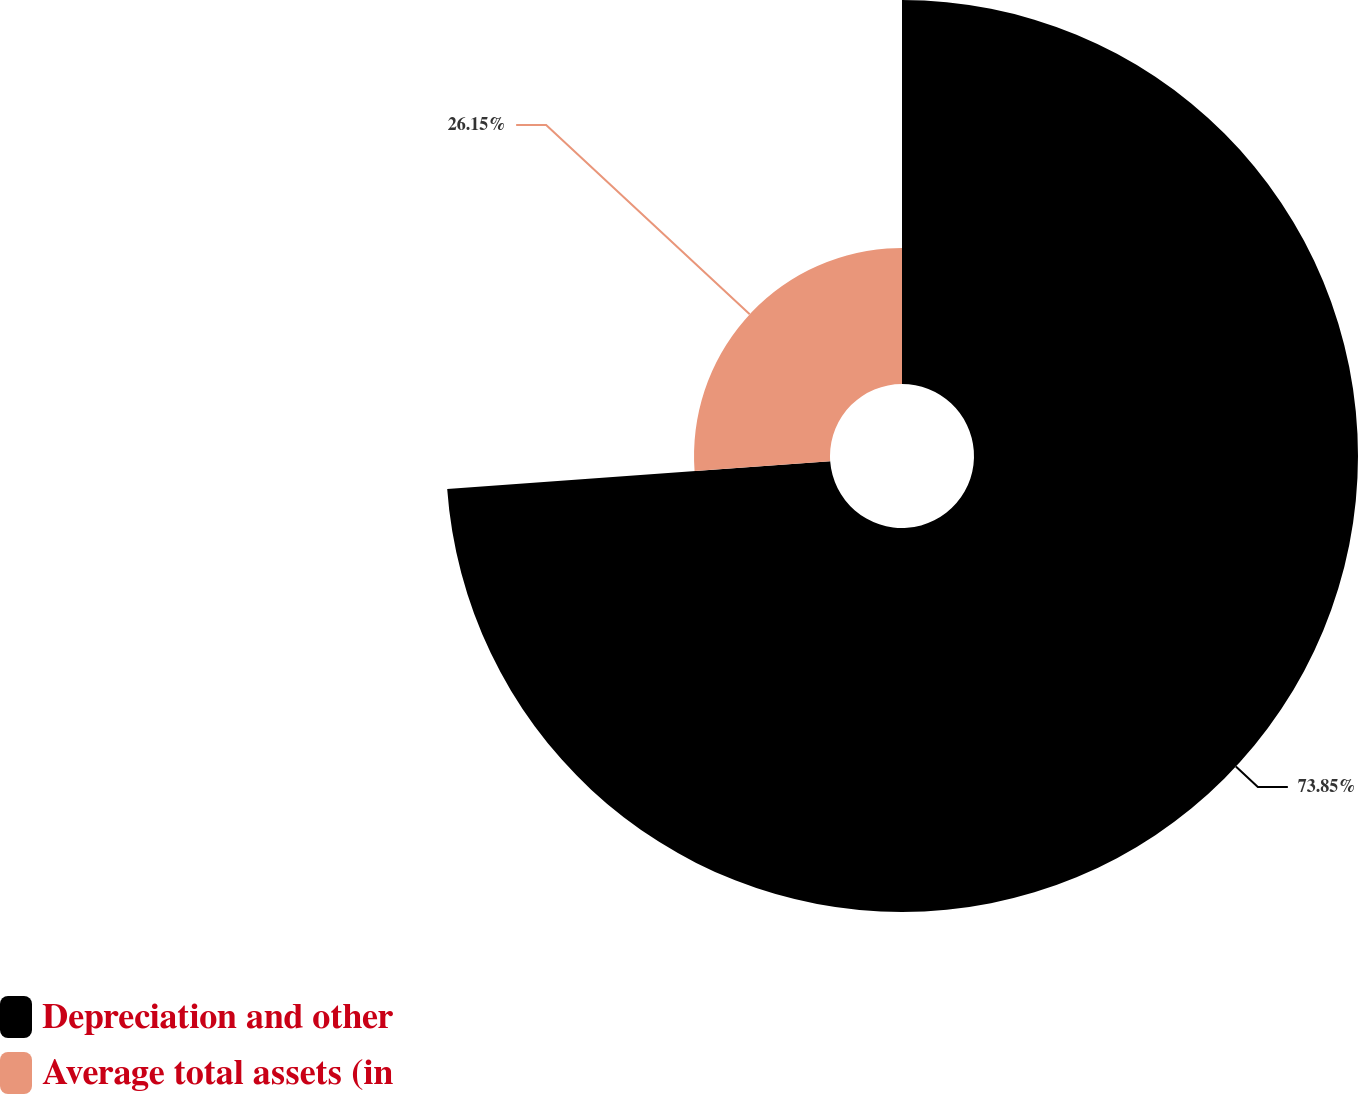<chart> <loc_0><loc_0><loc_500><loc_500><pie_chart><fcel>Depreciation and other<fcel>Average total assets (in<nl><fcel>73.85%<fcel>26.15%<nl></chart> 